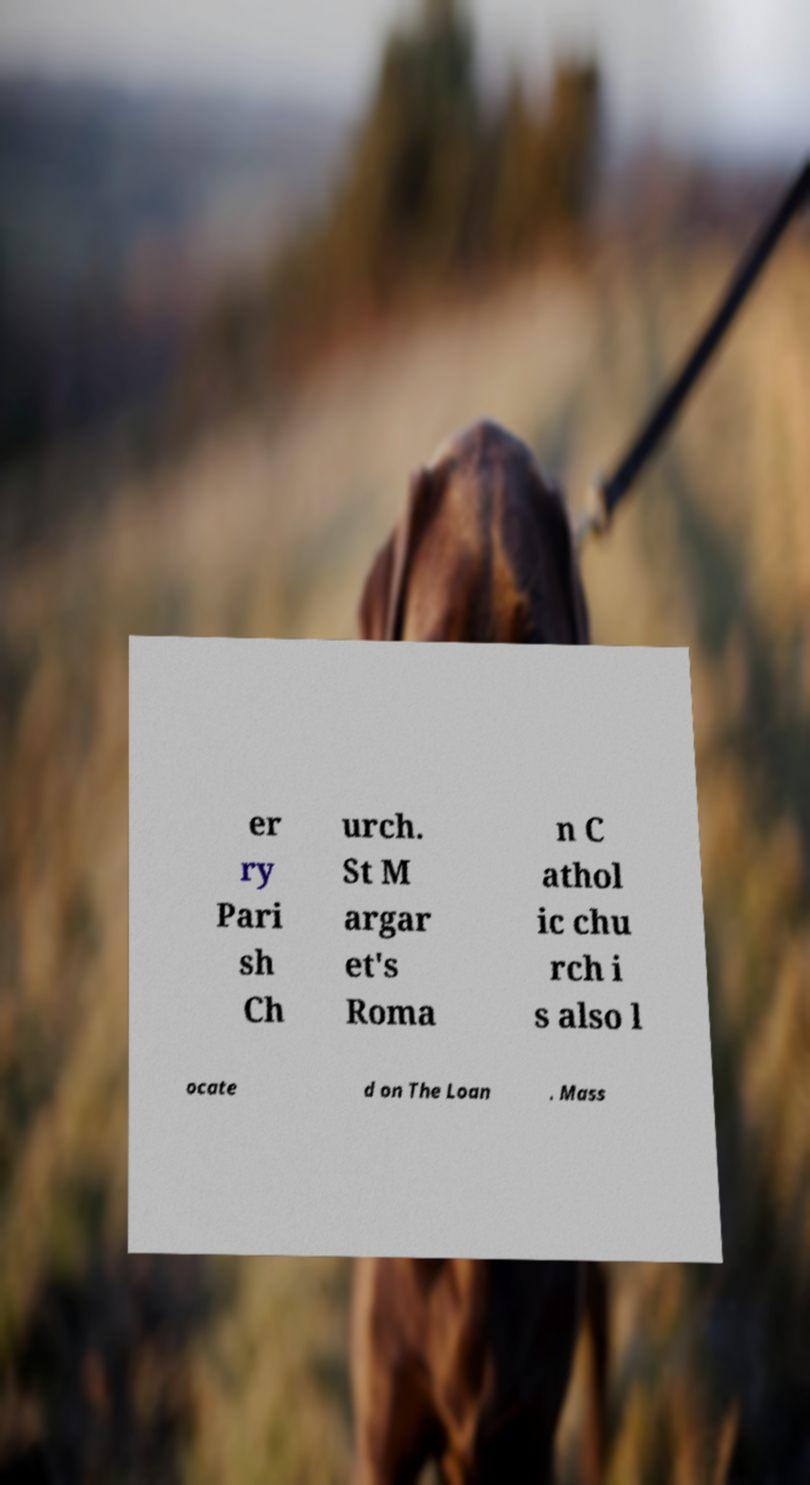Please read and relay the text visible in this image. What does it say? er ry Pari sh Ch urch. St M argar et's Roma n C athol ic chu rch i s also l ocate d on The Loan . Mass 